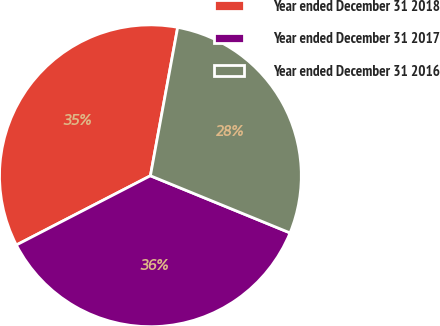Convert chart. <chart><loc_0><loc_0><loc_500><loc_500><pie_chart><fcel>Year ended December 31 2018<fcel>Year ended December 31 2017<fcel>Year ended December 31 2016<nl><fcel>35.48%<fcel>36.23%<fcel>28.29%<nl></chart> 